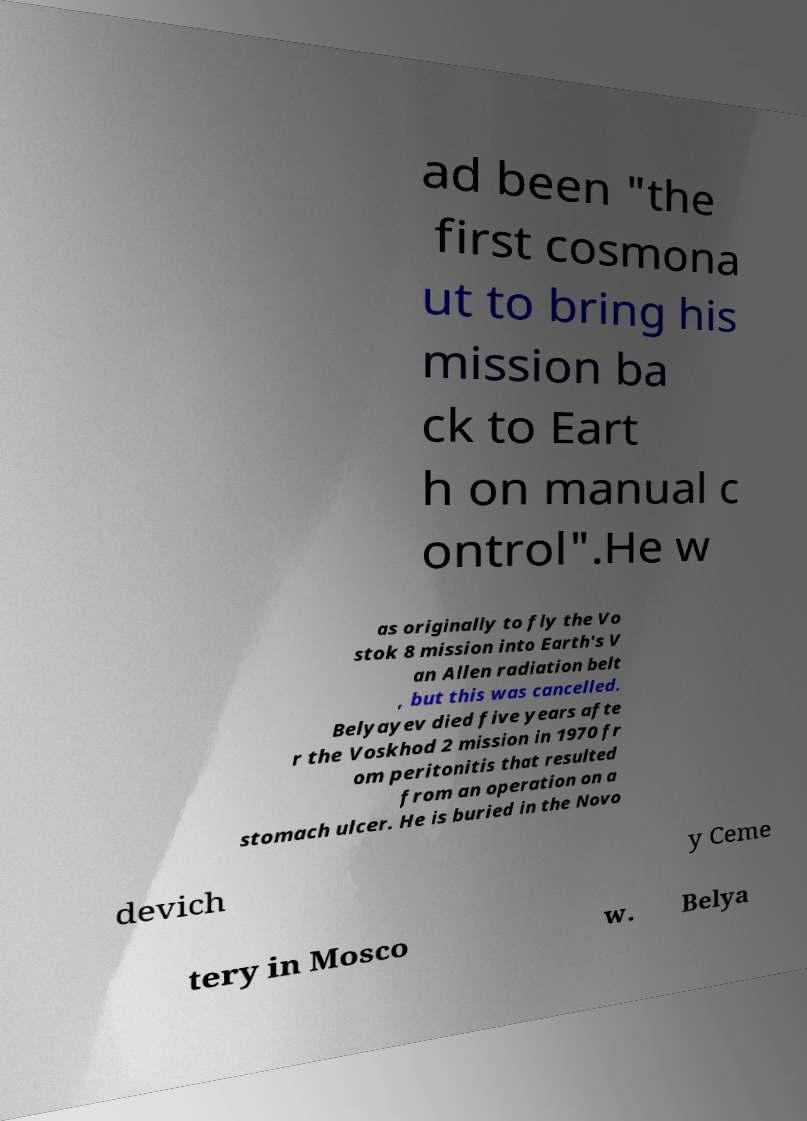Can you accurately transcribe the text from the provided image for me? ad been "the first cosmona ut to bring his mission ba ck to Eart h on manual c ontrol".He w as originally to fly the Vo stok 8 mission into Earth's V an Allen radiation belt , but this was cancelled. Belyayev died five years afte r the Voskhod 2 mission in 1970 fr om peritonitis that resulted from an operation on a stomach ulcer. He is buried in the Novo devich y Ceme tery in Mosco w. Belya 